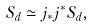Convert formula to latex. <formula><loc_0><loc_0><loc_500><loc_500>S _ { d } \simeq j _ { * } j ^ { * } S _ { d } ,</formula> 